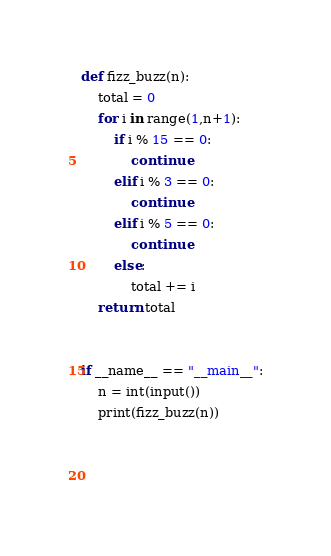<code> <loc_0><loc_0><loc_500><loc_500><_Python_>def fizz_buzz(n):
    total = 0
    for i in range(1,n+1):
        if i % 15 == 0:
            continue
        elif i % 3 == 0:
            continue
        elif i % 5 == 0:
            continue
        else:
            total += i
    return total


if __name__ == "__main__":
    n = int(input())
    print(fizz_buzz(n))
    

    </code> 